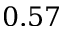Convert formula to latex. <formula><loc_0><loc_0><loc_500><loc_500>0 . 5 7</formula> 